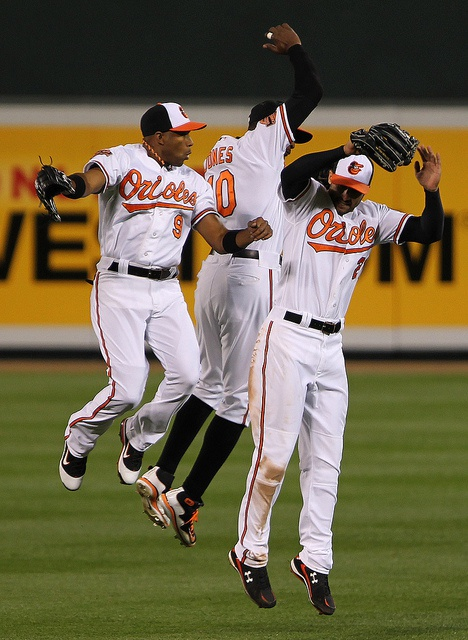Describe the objects in this image and their specific colors. I can see people in black, lavender, darkgreen, and darkgray tones, people in black, lavender, darkgray, and maroon tones, people in black, darkgray, lavender, and gray tones, baseball glove in black, gray, olive, and darkgray tones, and baseball glove in black, gray, maroon, and olive tones in this image. 